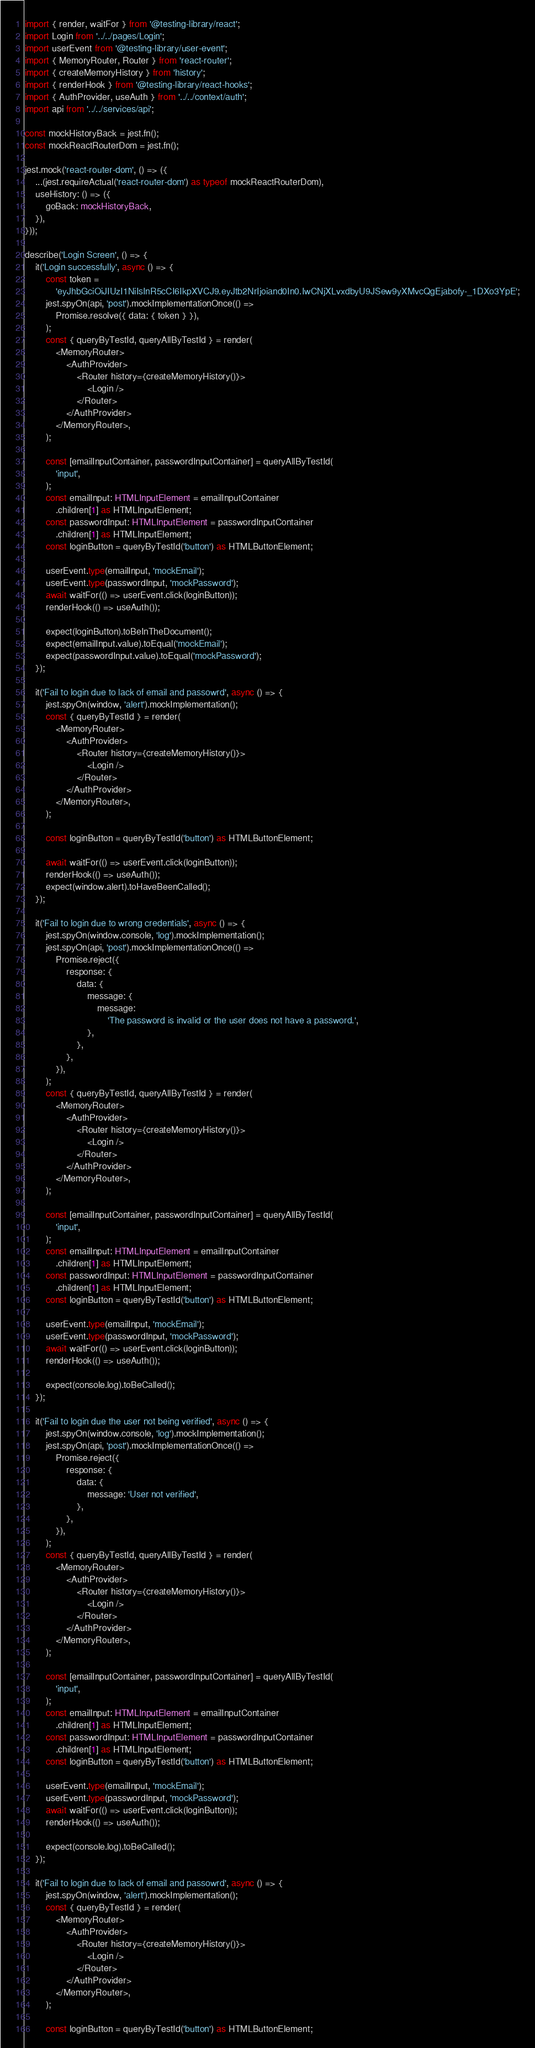<code> <loc_0><loc_0><loc_500><loc_500><_TypeScript_>import { render, waitFor } from '@testing-library/react';
import Login from '../../pages/Login';
import userEvent from '@testing-library/user-event';
import { MemoryRouter, Router } from 'react-router';
import { createMemoryHistory } from 'history';
import { renderHook } from '@testing-library/react-hooks';
import { AuthProvider, useAuth } from '../../context/auth';
import api from '../../services/api';

const mockHistoryBack = jest.fn();
const mockReactRouterDom = jest.fn();

jest.mock('react-router-dom', () => ({
	...(jest.requireActual('react-router-dom') as typeof mockReactRouterDom),
	useHistory: () => ({
		goBack: mockHistoryBack,
	}),
}));

describe('Login Screen', () => {
	it('Login successfully', async () => {
		const token =
			'eyJhbGciOiJIUzI1NiIsInR5cCI6IkpXVCJ9.eyJtb2NrIjoiand0In0.IwCNjXLvxdbyU9JSew9yXMvcQgEjabofy-_1DXo3YpE';
		jest.spyOn(api, 'post').mockImplementationOnce(() =>
			Promise.resolve({ data: { token } }),
		);
		const { queryByTestId, queryAllByTestId } = render(
			<MemoryRouter>
				<AuthProvider>
					<Router history={createMemoryHistory()}>
						<Login />
					</Router>
				</AuthProvider>
			</MemoryRouter>,
		);

		const [emailInputContainer, passwordInputContainer] = queryAllByTestId(
			'input',
		);
		const emailInput: HTMLInputElement = emailInputContainer
			.children[1] as HTMLInputElement;
		const passwordInput: HTMLInputElement = passwordInputContainer
			.children[1] as HTMLInputElement;
		const loginButton = queryByTestId('button') as HTMLButtonElement;

		userEvent.type(emailInput, 'mockEmail');
		userEvent.type(passwordInput, 'mockPassword');
		await waitFor(() => userEvent.click(loginButton));
		renderHook(() => useAuth());

		expect(loginButton).toBeInTheDocument();
		expect(emailInput.value).toEqual('mockEmail');
		expect(passwordInput.value).toEqual('mockPassword');
	});

	it('Fail to login due to lack of email and passowrd', async () => {
		jest.spyOn(window, 'alert').mockImplementation();
		const { queryByTestId } = render(
			<MemoryRouter>
				<AuthProvider>
					<Router history={createMemoryHistory()}>
						<Login />
					</Router>
				</AuthProvider>
			</MemoryRouter>,
		);

		const loginButton = queryByTestId('button') as HTMLButtonElement;

		await waitFor(() => userEvent.click(loginButton));
		renderHook(() => useAuth());
		expect(window.alert).toHaveBeenCalled();
	});

	it('Fail to login due to wrong credentials', async () => {
		jest.spyOn(window.console, 'log').mockImplementation();
		jest.spyOn(api, 'post').mockImplementationOnce(() =>
			Promise.reject({
				response: {
					data: {
						message: {
							message:
								'The password is invalid or the user does not have a password.',
						},
					},
				},
			}),
		);
		const { queryByTestId, queryAllByTestId } = render(
			<MemoryRouter>
				<AuthProvider>
					<Router history={createMemoryHistory()}>
						<Login />
					</Router>
				</AuthProvider>
			</MemoryRouter>,
		);

		const [emailInputContainer, passwordInputContainer] = queryAllByTestId(
			'input',
		);
		const emailInput: HTMLInputElement = emailInputContainer
			.children[1] as HTMLInputElement;
		const passwordInput: HTMLInputElement = passwordInputContainer
			.children[1] as HTMLInputElement;
		const loginButton = queryByTestId('button') as HTMLButtonElement;

		userEvent.type(emailInput, 'mockEmail');
		userEvent.type(passwordInput, 'mockPassword');
		await waitFor(() => userEvent.click(loginButton));
		renderHook(() => useAuth());

		expect(console.log).toBeCalled();
	});

	it('Fail to login due the user not being verified', async () => {
		jest.spyOn(window.console, 'log').mockImplementation();
		jest.spyOn(api, 'post').mockImplementationOnce(() =>
			Promise.reject({
				response: {
					data: {
						message: 'User not verified',
					},
				},
			}),
		);
		const { queryByTestId, queryAllByTestId } = render(
			<MemoryRouter>
				<AuthProvider>
					<Router history={createMemoryHistory()}>
						<Login />
					</Router>
				</AuthProvider>
			</MemoryRouter>,
		);

		const [emailInputContainer, passwordInputContainer] = queryAllByTestId(
			'input',
		);
		const emailInput: HTMLInputElement = emailInputContainer
			.children[1] as HTMLInputElement;
		const passwordInput: HTMLInputElement = passwordInputContainer
			.children[1] as HTMLInputElement;
		const loginButton = queryByTestId('button') as HTMLButtonElement;

		userEvent.type(emailInput, 'mockEmail');
		userEvent.type(passwordInput, 'mockPassword');
		await waitFor(() => userEvent.click(loginButton));
		renderHook(() => useAuth());

		expect(console.log).toBeCalled();
	});

	it('Fail to login due to lack of email and passowrd', async () => {
		jest.spyOn(window, 'alert').mockImplementation();
		const { queryByTestId } = render(
			<MemoryRouter>
				<AuthProvider>
					<Router history={createMemoryHistory()}>
						<Login />
					</Router>
				</AuthProvider>
			</MemoryRouter>,
		);

		const loginButton = queryByTestId('button') as HTMLButtonElement;
</code> 